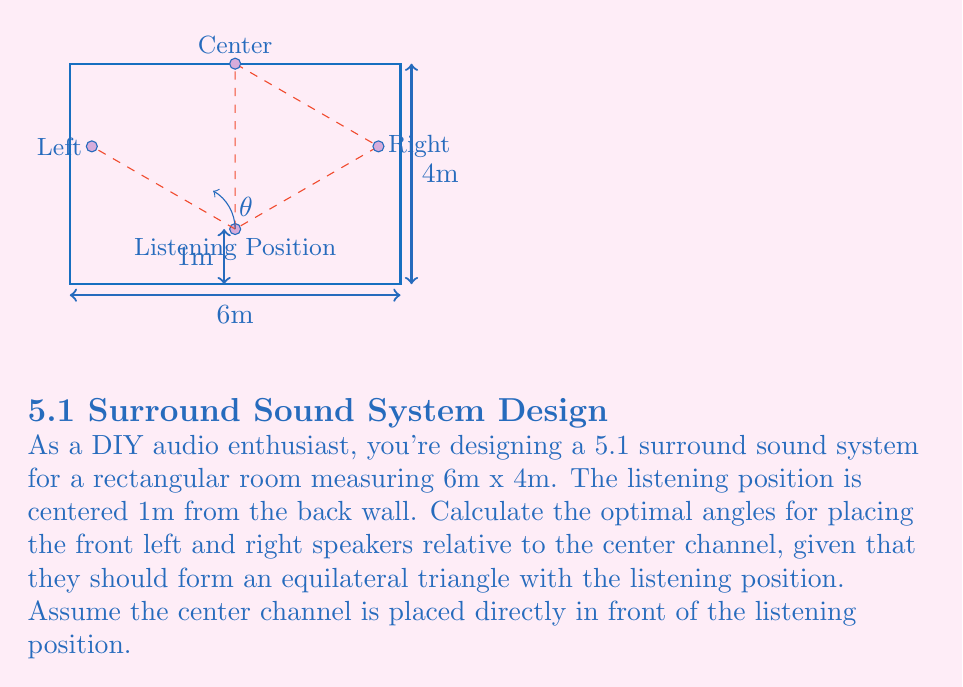Provide a solution to this math problem. Let's approach this step-by-step:

1) In an equilateral triangle, all sides are equal and all angles are 60°.

2) The distance from the listening position to the back wall is 1m, so the distance to the front wall is 3m (4m - 1m).

3) We need to find the angle $\theta$ between the center line and the line to each front speaker.

4) In an equilateral triangle, the height (h) is given by:
   $$h = \frac{\sqrt{3}}{2} * side$$

5) The side of our equilateral triangle is 3m (the distance from listening position to front wall).

6) So the height of our triangle is:
   $$h = \frac{\sqrt{3}}{2} * 3 = \frac{3\sqrt{3}}{2} \approx 2.598m$$

7) Now we can use the tangent function to find the angle:
   $$\tan(\theta) = \frac{opposite}{adjacent} = \frac{1.5}{2.598}$$

8) Solving for $\theta$:
   $$\theta = \arctan(\frac{1.5}{2.598}) \approx 30°$$

9) This matches our expectation, as 30° is half of 60°, which is the angle at the top of an equilateral triangle.

Therefore, the optimal angle for placing each front speaker relative to the center channel is approximately 30°.
Answer: 30° 